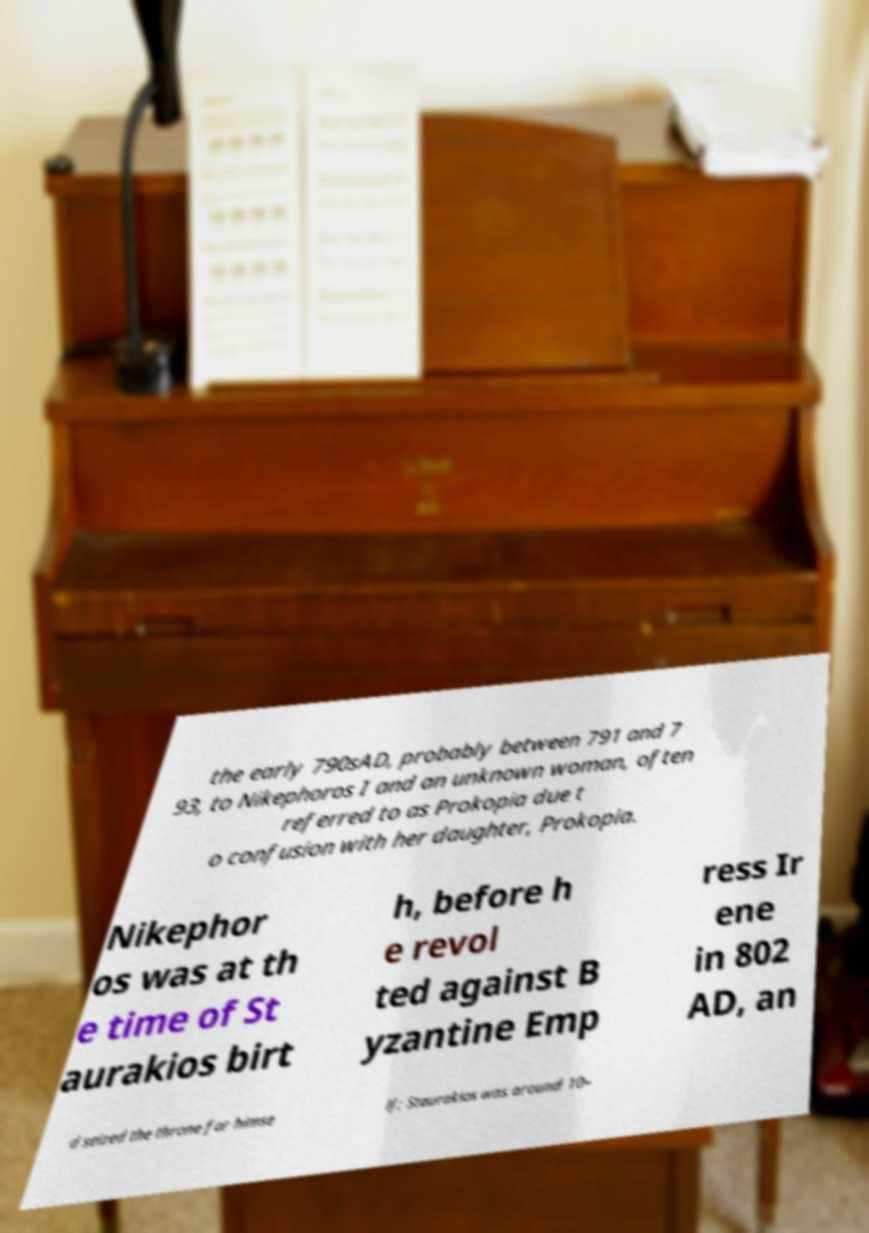For documentation purposes, I need the text within this image transcribed. Could you provide that? the early 790sAD, probably between 791 and 7 93, to Nikephoros I and an unknown woman, often referred to as Prokopia due t o confusion with her daughter, Prokopia. Nikephor os was at th e time of St aurakios birt h, before h e revol ted against B yzantine Emp ress Ir ene in 802 AD, an d seized the throne for himse lf; Staurakios was around 10– 